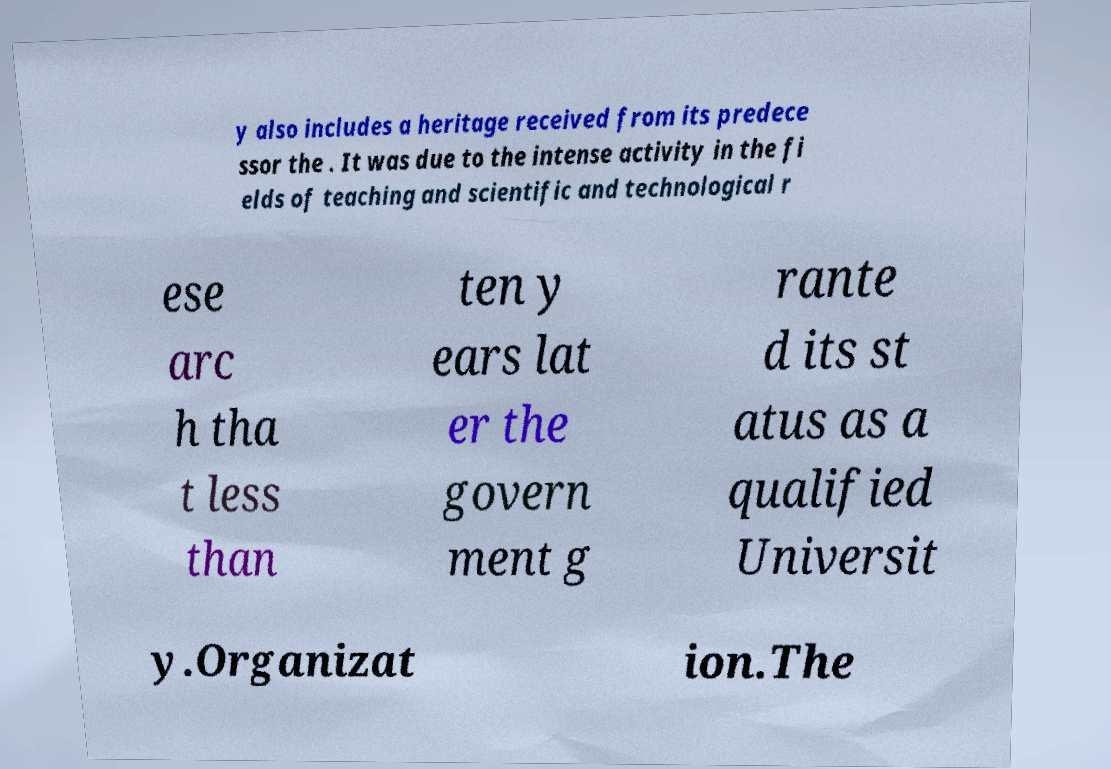I need the written content from this picture converted into text. Can you do that? y also includes a heritage received from its predece ssor the . It was due to the intense activity in the fi elds of teaching and scientific and technological r ese arc h tha t less than ten y ears lat er the govern ment g rante d its st atus as a qualified Universit y.Organizat ion.The 